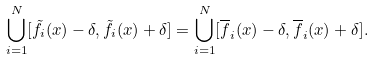<formula> <loc_0><loc_0><loc_500><loc_500>\bigcup _ { i = 1 } ^ { N } [ \tilde { f } _ { i } ( x ) - \delta , \tilde { f } _ { i } ( x ) + \delta ] = \bigcup _ { i = 1 } ^ { N } [ \overline { f } _ { i } ( x ) - \delta , \overline { f } _ { i } ( x ) + \delta ] .</formula> 